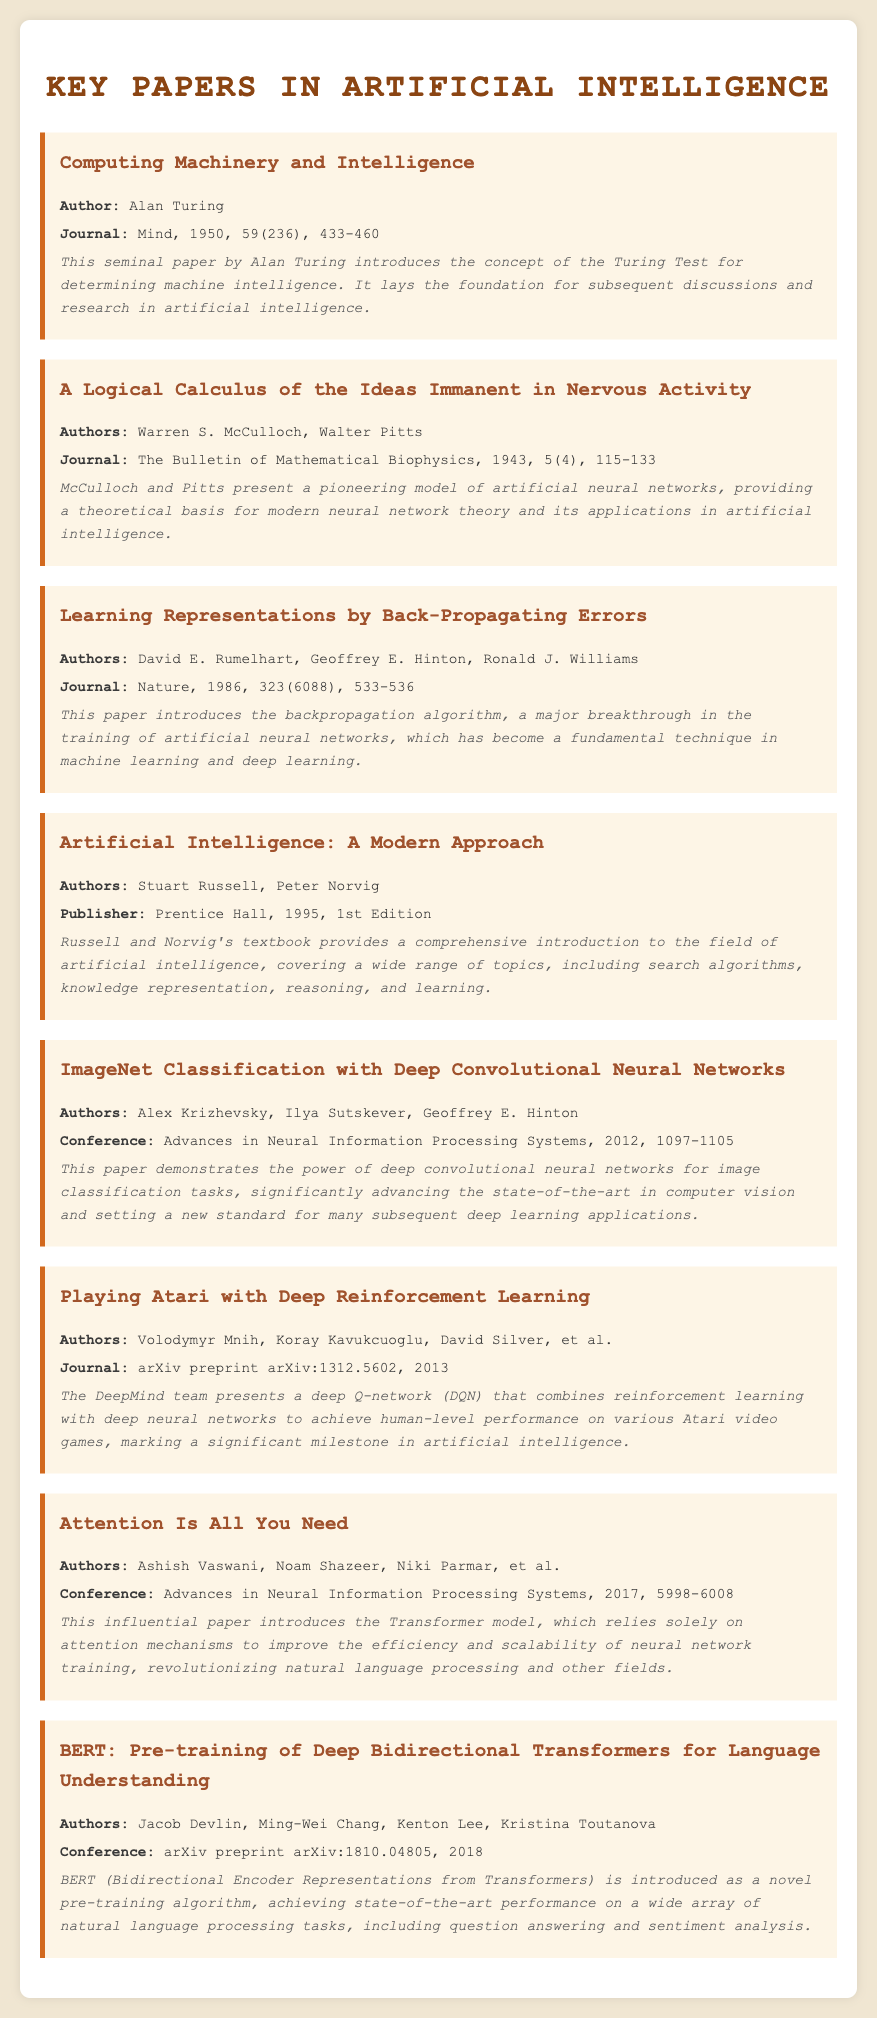what is the title of Alan Turing's paper? The title is listed in the document under Turing's section, which is "Computing Machinery and Intelligence."
Answer: Computing Machinery and Intelligence who are the authors of the paper on artificial neural networks? The authors are mentioned in McCulloch and Pitts' section, which includes their names, Warren S. McCulloch and Walter Pitts.
Answer: Warren S. McCulloch, Walter Pitts what year was the backpropagation paper published? The publication year is provided in the citation of the paper by Rumelhart, Hinton, and Williams, which is 1986.
Answer: 1986 who published "Artificial Intelligence: A Modern Approach"? The document lists Stuart Russell and Peter Norvig as the authors of this book.
Answer: Stuart Russell, Peter Norvig what is the main focus of the BERT paper? The abstract of the BERT paper describes it as a novel pre-training algorithm for language understanding.
Answer: Pre-training of Deep Bidirectional Transformers for Language Understanding which conference featured the Transformer model paper? The document notes that the paper "Attention Is All You Need" was featured at the Advances in Neural Information Processing Systems conference.
Answer: Advances in Neural Information Processing Systems how many authors contributed to the ImageNet paper? The authors' section shows three names for the ImageNet Classification paper.
Answer: Three what important algorithm was introduced in the backpropagation paper? The key concept introduced in the paper is mentioned as the backpropagation algorithm.
Answer: Backpropagation algorithm 